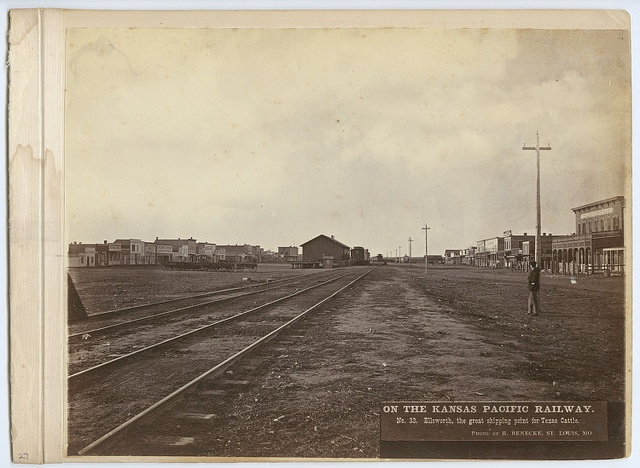Describe the objects in this image and their specific colors. I can see people in lightgray, black, and gray tones and train in lightgray, black, and gray tones in this image. 